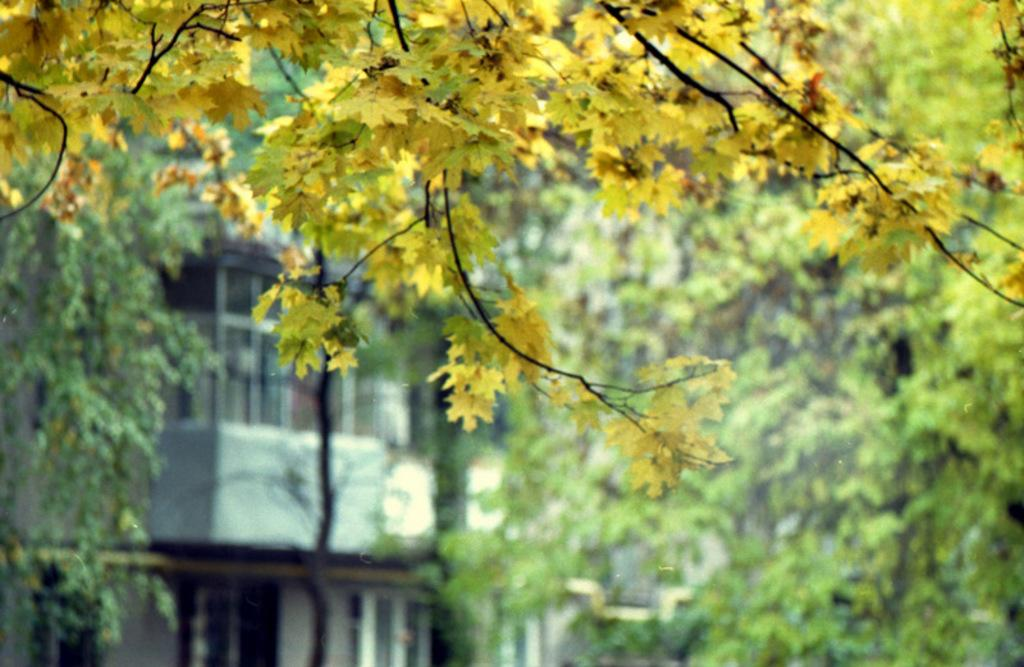What color are the leaves on the tree in the foreground of the image? The leaves on the tree in the foreground of the image are yellow. What can be seen in the background of the image? There are trees and buildings in the background of the image. How many nails are visible on the tree in the image? There are no nails visible on the tree in the image. What is the condition of the minute hand on the tree in the image? There is no clock or minute hand present on the tree in the image. 